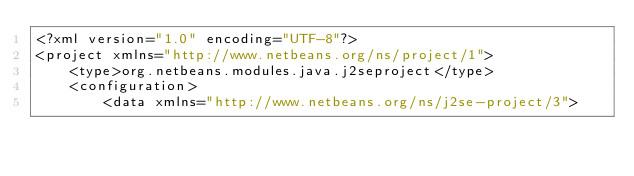Convert code to text. <code><loc_0><loc_0><loc_500><loc_500><_XML_><?xml version="1.0" encoding="UTF-8"?>
<project xmlns="http://www.netbeans.org/ns/project/1">
    <type>org.netbeans.modules.java.j2seproject</type>
    <configuration>
        <data xmlns="http://www.netbeans.org/ns/j2se-project/3"></code> 